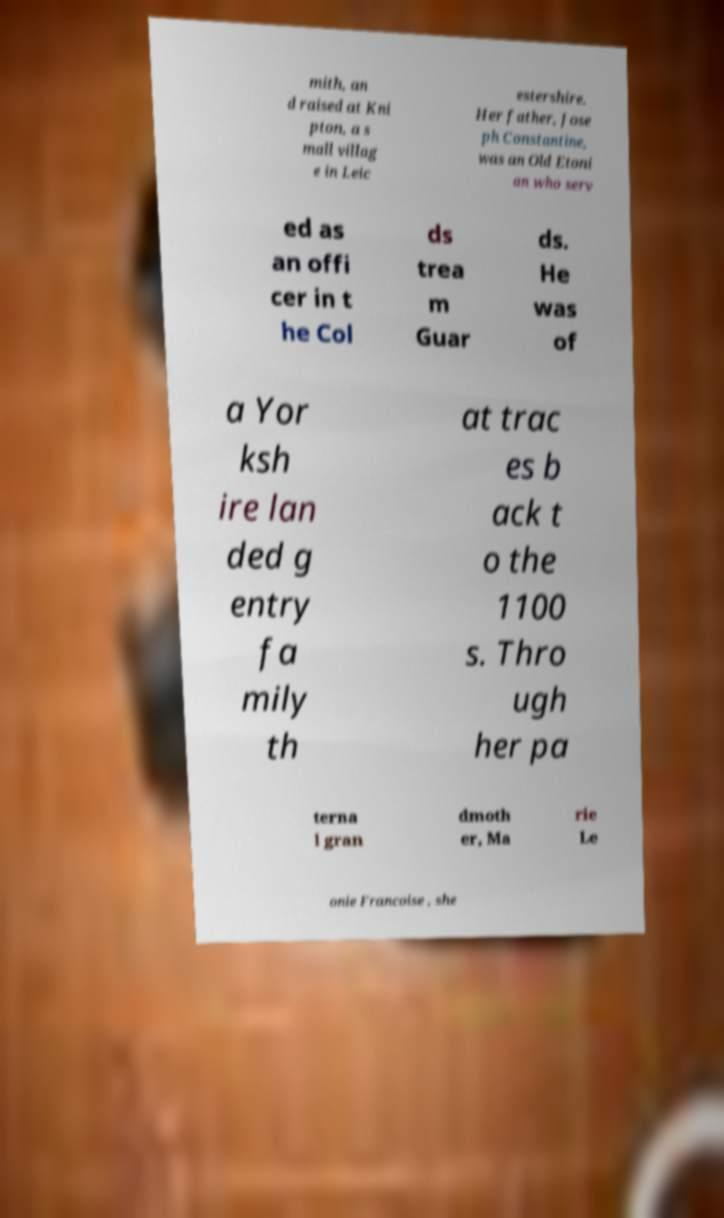I need the written content from this picture converted into text. Can you do that? mith, an d raised at Kni pton, a s mall villag e in Leic estershire. Her father, Jose ph Constantine, was an Old Etoni an who serv ed as an offi cer in t he Col ds trea m Guar ds. He was of a Yor ksh ire lan ded g entry fa mily th at trac es b ack t o the 1100 s. Thro ugh her pa terna l gran dmoth er, Ma rie Le onie Francoise , she 